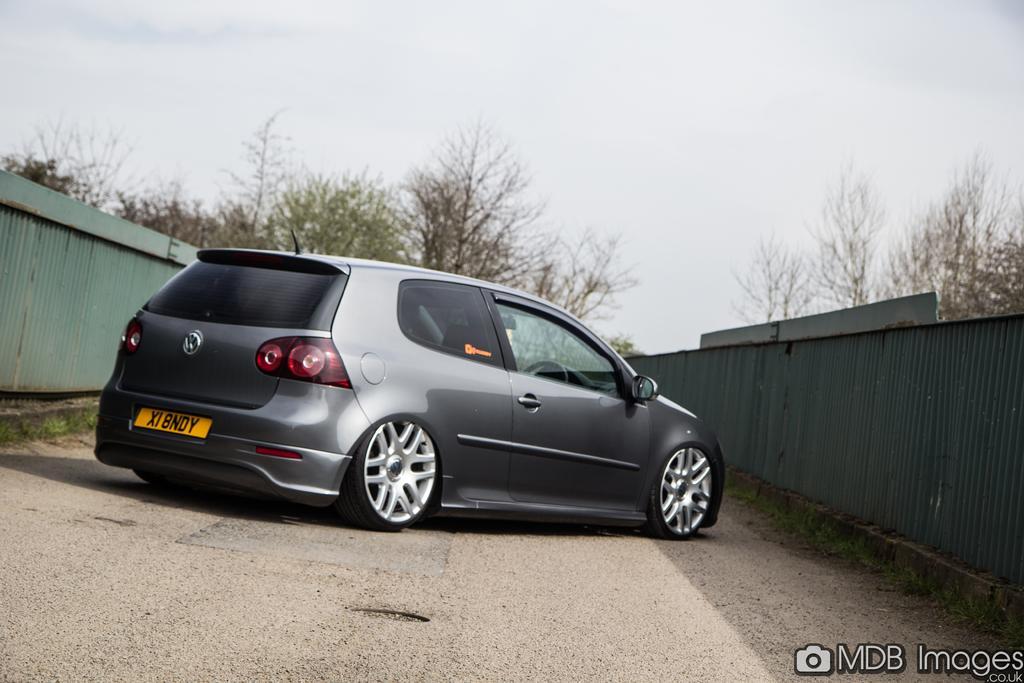Could you give a brief overview of what you see in this image? In the image there is a car on the road. On both sides of the image there is fencing. In the background there are trees. At the top of the image there is sky. In the bottom right corner of the image there is text. 